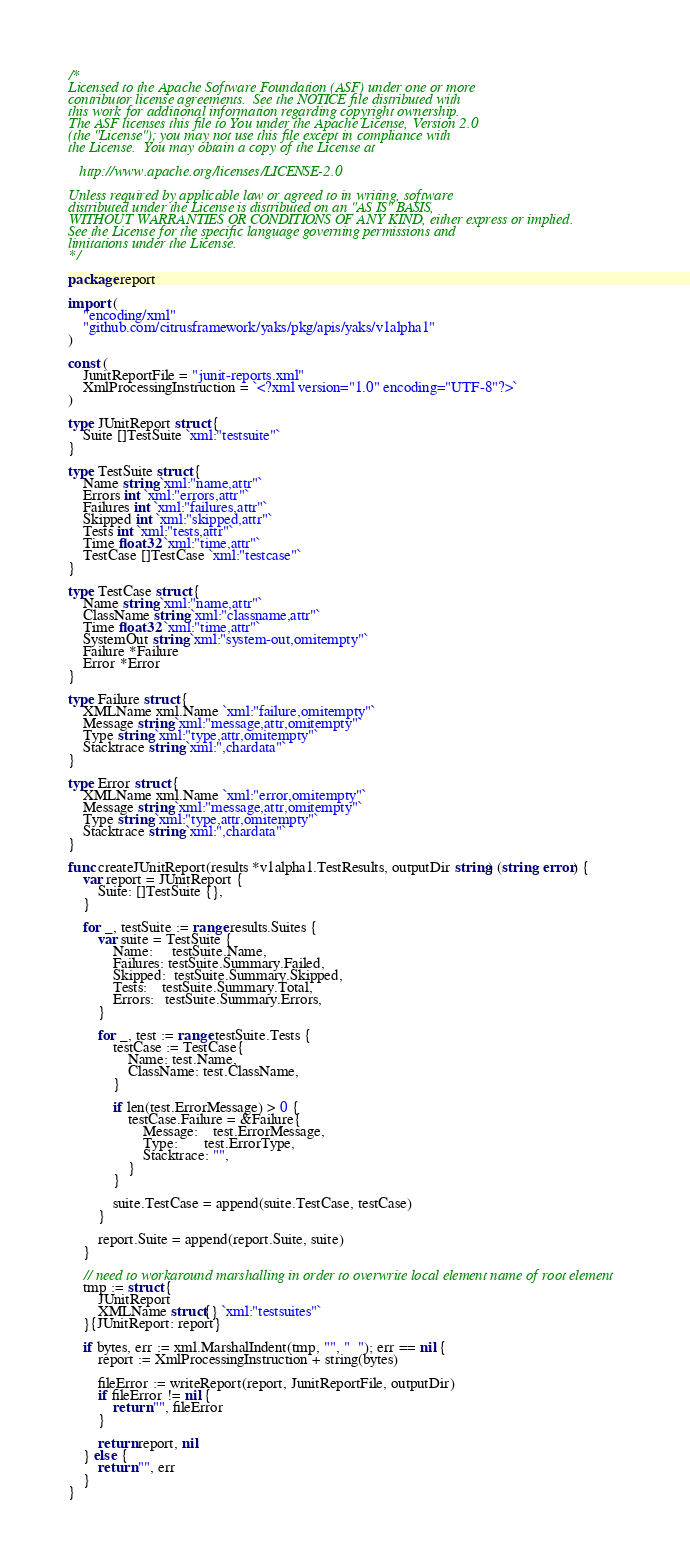<code> <loc_0><loc_0><loc_500><loc_500><_Go_>/*
Licensed to the Apache Software Foundation (ASF) under one or more
contributor license agreements.  See the NOTICE file distributed with
this work for additional information regarding copyright ownership.
The ASF licenses this file to You under the Apache License, Version 2.0
(the "License"); you may not use this file except in compliance with
the License.  You may obtain a copy of the License at

   http://www.apache.org/licenses/LICENSE-2.0

Unless required by applicable law or agreed to in writing, software
distributed under the License is distributed on an "AS IS" BASIS,
WITHOUT WARRANTIES OR CONDITIONS OF ANY KIND, either express or implied.
See the License for the specific language governing permissions and
limitations under the License.
*/

package report

import (
	"encoding/xml"
	"github.com/citrusframework/yaks/pkg/apis/yaks/v1alpha1"
)

const (
	JunitReportFile = "junit-reports.xml"
	XmlProcessingInstruction = `<?xml version="1.0" encoding="UTF-8"?>`
)

type JUnitReport struct {
	Suite []TestSuite `xml:"testsuite"`
}

type TestSuite struct {
	Name string `xml:"name,attr"`
	Errors int `xml:"errors,attr"`
	Failures int `xml:"failures,attr"`
	Skipped int `xml:"skipped,attr"`
	Tests int `xml:"tests,attr"`
	Time float32 `xml:"time,attr"`
	TestCase []TestCase `xml:"testcase"`
}

type TestCase struct {
	Name string `xml:"name,attr"`
	ClassName string `xml:"classname,attr"`
	Time float32 `xml:"time,attr"`
	SystemOut string `xml:"system-out,omitempty"`
	Failure *Failure
	Error *Error
}

type Failure struct {
	XMLName xml.Name `xml:"failure,omitempty"`
	Message string `xml:"message,attr,omitempty"`
	Type string `xml:"type,attr,omitempty"`
	Stacktrace string `xml:",chardata"`
}

type Error struct {
	XMLName xml.Name `xml:"error,omitempty"`
	Message string `xml:"message,attr,omitempty"`
	Type string `xml:"type,attr,omitempty"`
	Stacktrace string `xml:",chardata"`
}

func createJUnitReport(results *v1alpha1.TestResults, outputDir string) (string, error) {
	var report = JUnitReport {
		Suite: []TestSuite {},
	}

	for _, testSuite := range results.Suites {
		var suite = TestSuite {
			Name:     testSuite.Name,
			Failures: testSuite.Summary.Failed,
			Skipped:  testSuite.Summary.Skipped,
			Tests:    testSuite.Summary.Total,
			Errors:   testSuite.Summary.Errors,
		}

		for _, test := range testSuite.Tests {
			testCase := TestCase{
				Name: test.Name,
				ClassName: test.ClassName,
			}

			if len(test.ErrorMessage) > 0 {
				testCase.Failure = &Failure{
					Message:    test.ErrorMessage,
					Type:       test.ErrorType,
					Stacktrace: "",
				}
			}

			suite.TestCase = append(suite.TestCase, testCase)
		}

		report.Suite = append(report.Suite, suite)
	}

	// need to workaround marshalling in order to overwrite local element name of root element
	tmp := struct {
		JUnitReport
		XMLName struct{} `xml:"testsuites"`
	}{JUnitReport: report}

	if bytes, err := xml.MarshalIndent(tmp, "", "  "); err == nil {
		report := XmlProcessingInstruction + string(bytes)

		fileError := writeReport(report, JunitReportFile, outputDir)
		if fileError != nil {
			return "", fileError
		}

		return report, nil
	} else {
		return "", err
	}
}
</code> 